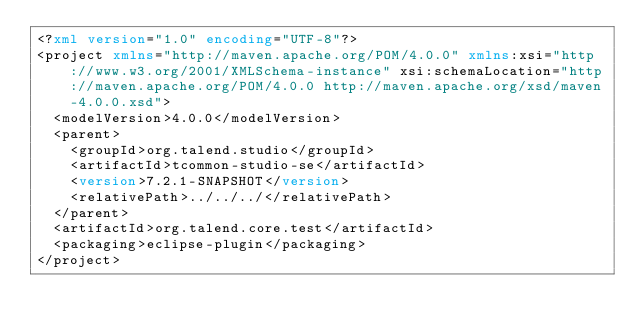<code> <loc_0><loc_0><loc_500><loc_500><_XML_><?xml version="1.0" encoding="UTF-8"?>
<project xmlns="http://maven.apache.org/POM/4.0.0" xmlns:xsi="http://www.w3.org/2001/XMLSchema-instance" xsi:schemaLocation="http://maven.apache.org/POM/4.0.0 http://maven.apache.org/xsd/maven-4.0.0.xsd">
  <modelVersion>4.0.0</modelVersion>
  <parent>
    <groupId>org.talend.studio</groupId>
    <artifactId>tcommon-studio-se</artifactId>
    <version>7.2.1-SNAPSHOT</version>
    <relativePath>../../../</relativePath>
  </parent>
  <artifactId>org.talend.core.test</artifactId>
  <packaging>eclipse-plugin</packaging>
</project>
</code> 